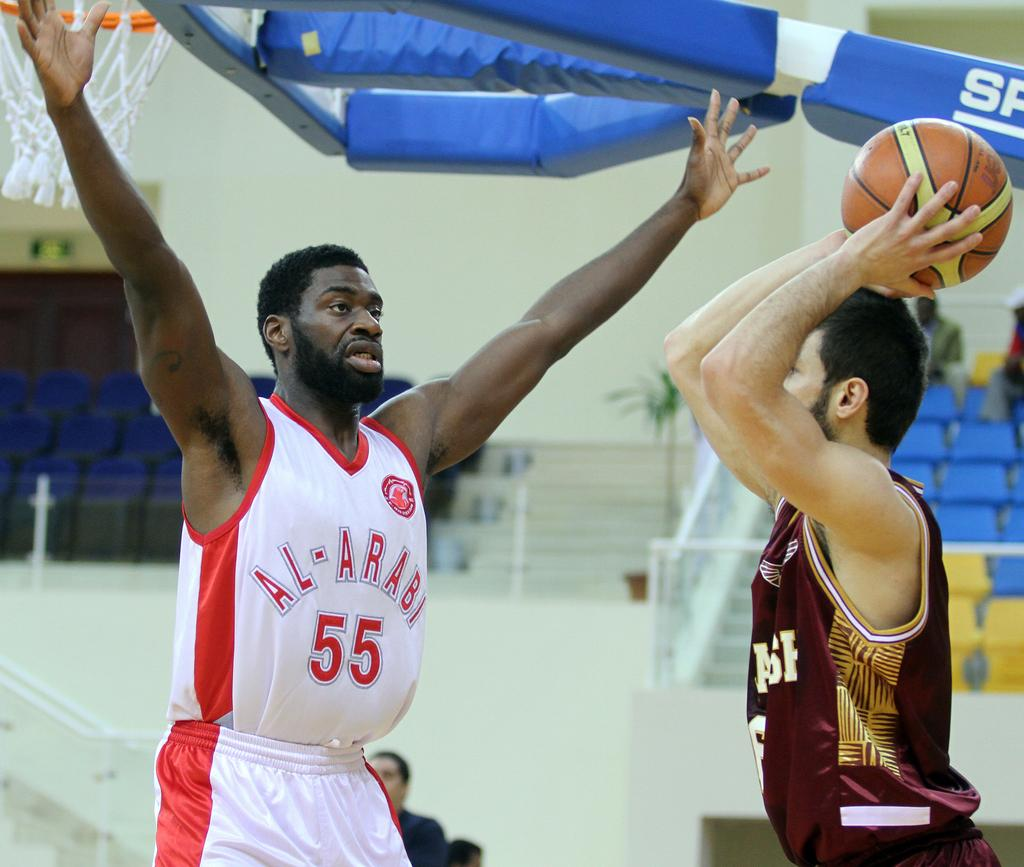<image>
Provide a brief description of the given image. A black man in an Al-Arabi basketball jersey tries to stop another man from throwing a ball. 